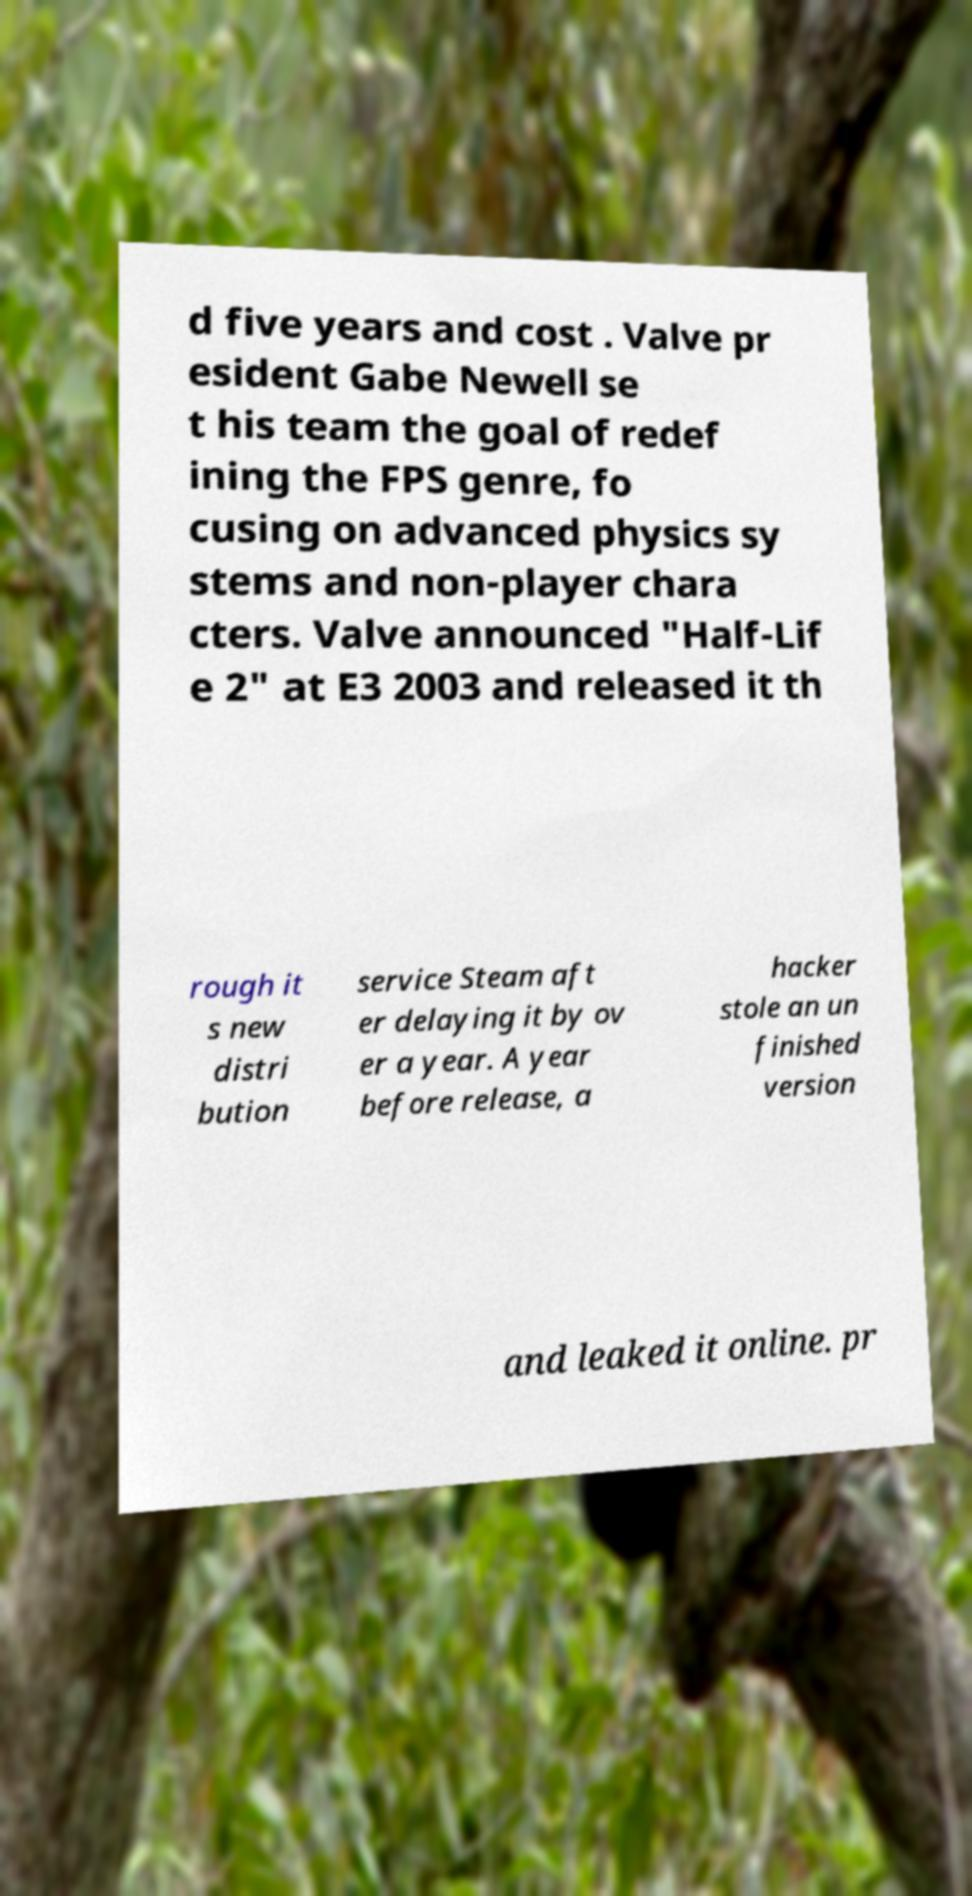What messages or text are displayed in this image? I need them in a readable, typed format. d five years and cost . Valve pr esident Gabe Newell se t his team the goal of redef ining the FPS genre, fo cusing on advanced physics sy stems and non-player chara cters. Valve announced "Half-Lif e 2" at E3 2003 and released it th rough it s new distri bution service Steam aft er delaying it by ov er a year. A year before release, a hacker stole an un finished version and leaked it online. pr 